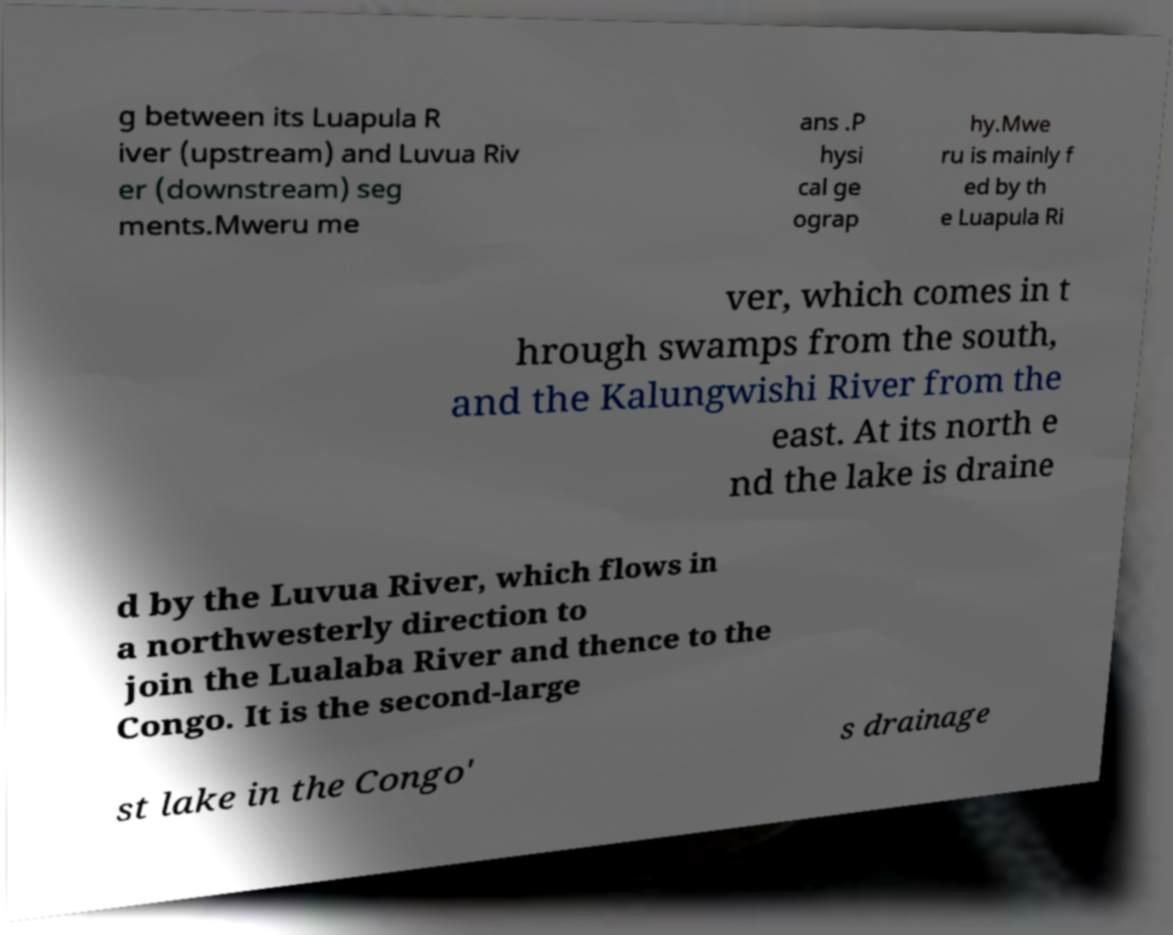Could you extract and type out the text from this image? g between its Luapula R iver (upstream) and Luvua Riv er (downstream) seg ments.Mweru me ans .P hysi cal ge ograp hy.Mwe ru is mainly f ed by th e Luapula Ri ver, which comes in t hrough swamps from the south, and the Kalungwishi River from the east. At its north e nd the lake is draine d by the Luvua River, which flows in a northwesterly direction to join the Lualaba River and thence to the Congo. It is the second-large st lake in the Congo' s drainage 